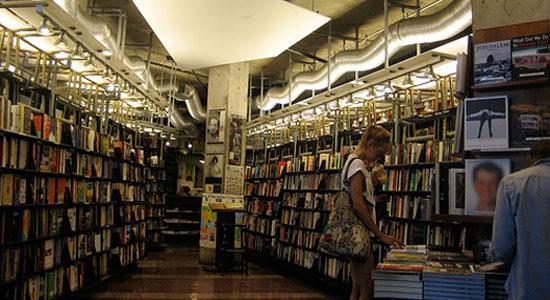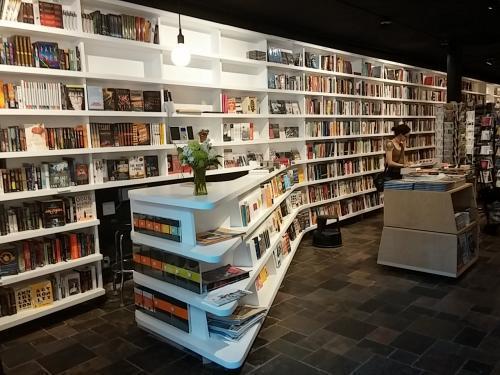The first image is the image on the left, the second image is the image on the right. For the images shown, is this caption "There are people looking at and reading books" true? Answer yes or no. Yes. The first image is the image on the left, the second image is the image on the right. Assess this claim about the two images: "All photos show only the exterior facade of the building.". Correct or not? Answer yes or no. No. 